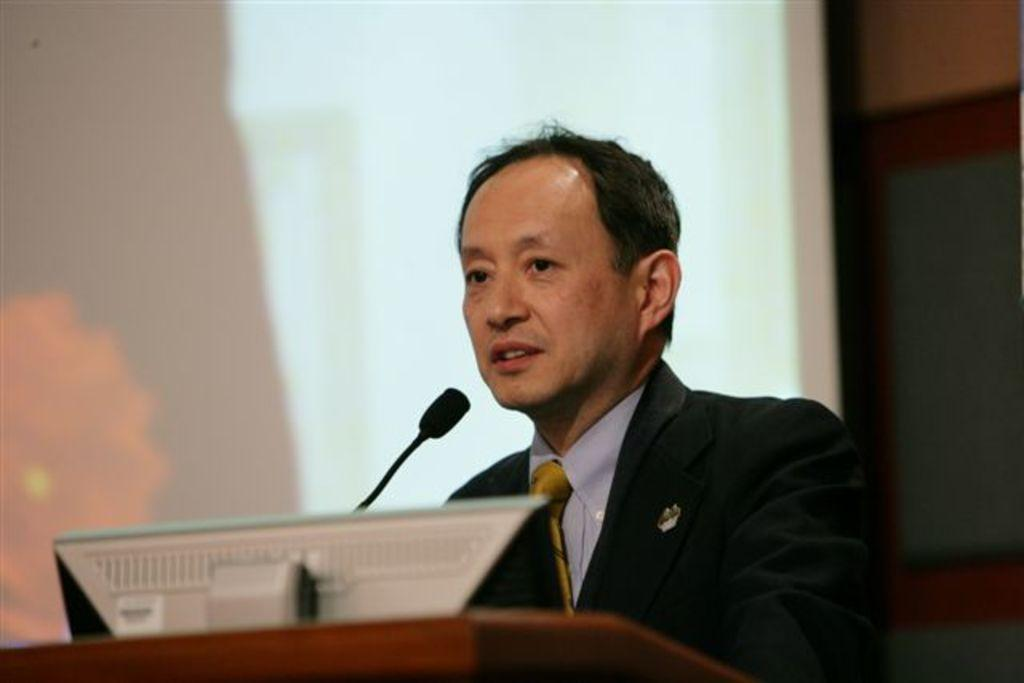What is the main subject of the image? There is a person in the image. What is the person wearing? The person is wearing a blazer and a tie. What is the person standing near in the image? There is a podium in the image, and the person is standing near it. What features does the podium have? The podium has a screen and a microphone on it. What is visible behind the person? There is a screen behind the person. What can be seen in the background of the image? The background of the image includes a wall. What type of mask is the person wearing in the image? There is no mask visible on the person in the image. What is the weather like in the downtown area during the day, as depicted in the image? The image does not provide information about the weather, downtown area, or time of day. 